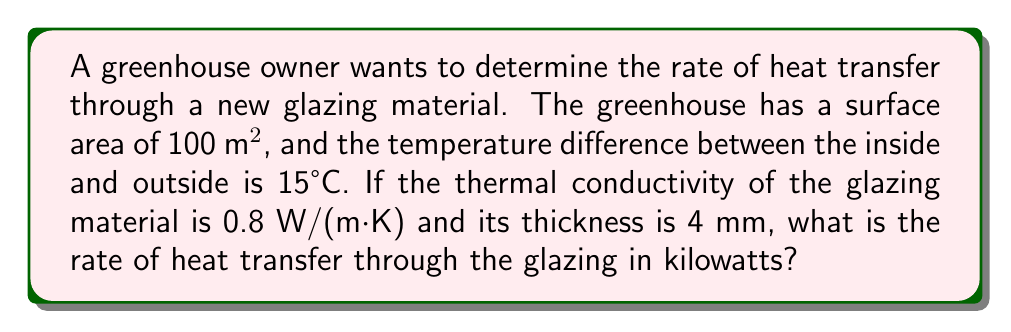Show me your answer to this math problem. To solve this problem, we'll use Fourier's law of heat conduction:

$$ Q = -k A \frac{dT}{dx} $$

Where:
$Q$ = rate of heat transfer (W)
$k$ = thermal conductivity (W/(m·K))
$A$ = surface area (m²)
$\frac{dT}{dx}$ = temperature gradient (K/m)

Step 1: Identify the given values
- Surface area, $A = 100$ m²
- Temperature difference, $\Delta T = 15°C = 15$ K
- Thermal conductivity, $k = 0.8$ W/(m·K)
- Thickness, $dx = 4$ mm $= 0.004$ m

Step 2: Calculate the temperature gradient
$\frac{dT}{dx} = \frac{\Delta T}{dx} = \frac{15}{0.004} = 3750$ K/m

Step 3: Apply Fourier's law
$Q = -k A \frac{dT}{dx}$
$Q = -0.8 \cdot 100 \cdot 3750 = -300,000$ W

Step 4: Convert the result to kilowatts
$Q = -300,000$ W $= -300$ kW

The negative sign indicates that heat is flowing from the warmer inside to the cooler outside. For the final answer, we'll report the absolute value.
Answer: 300 kW 